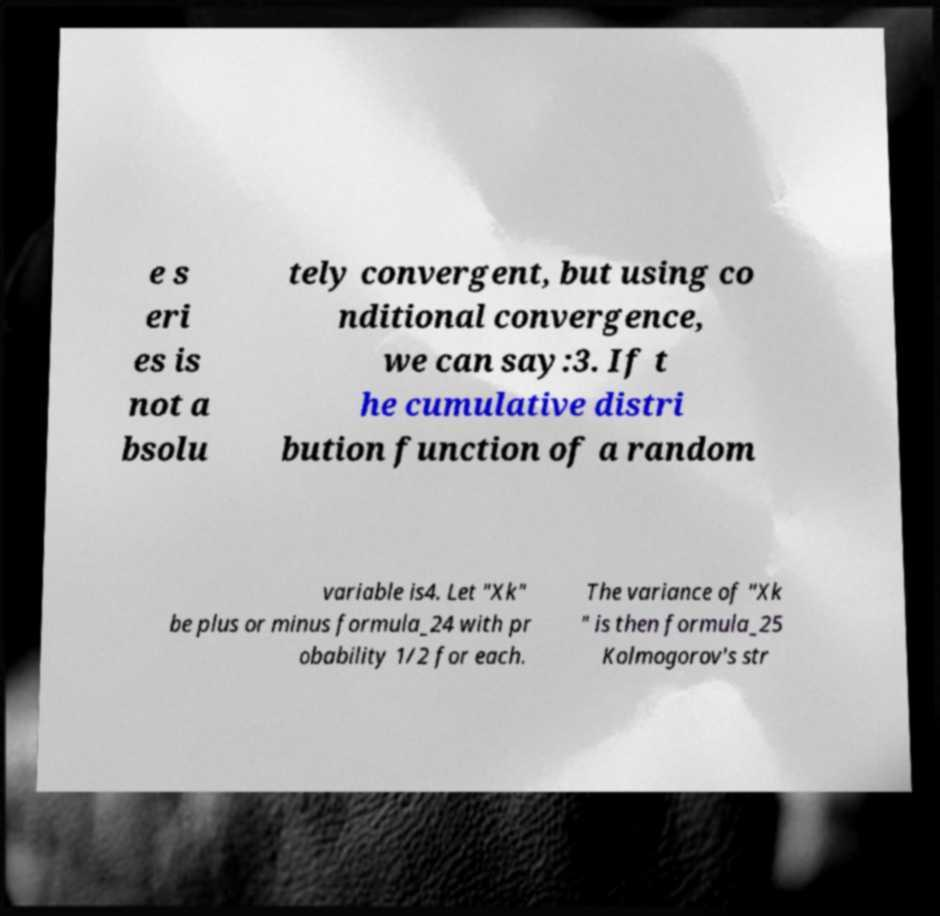Could you extract and type out the text from this image? e s eri es is not a bsolu tely convergent, but using co nditional convergence, we can say:3. If t he cumulative distri bution function of a random variable is4. Let "Xk" be plus or minus formula_24 with pr obability 1/2 for each. The variance of "Xk " is then formula_25 Kolmogorov's str 